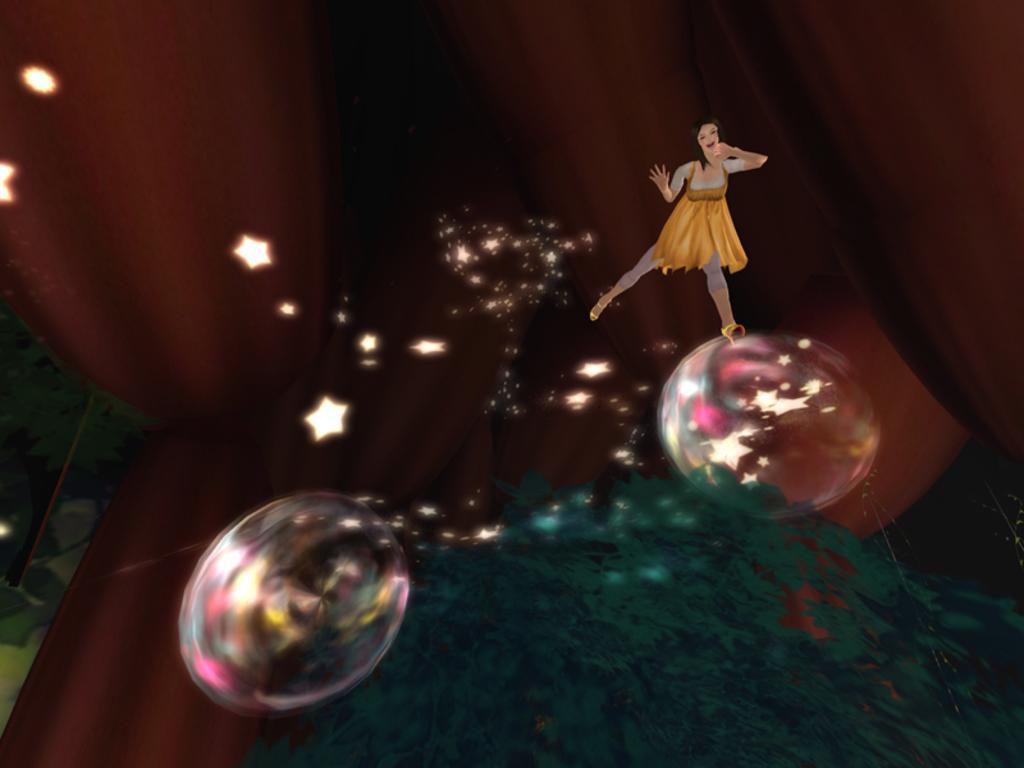Could you give a brief overview of what you see in this image? In this image in the front there are bubbles and in the center there is an object which is green in colour and there is a doll. In the background there is an object which is red in colour. 